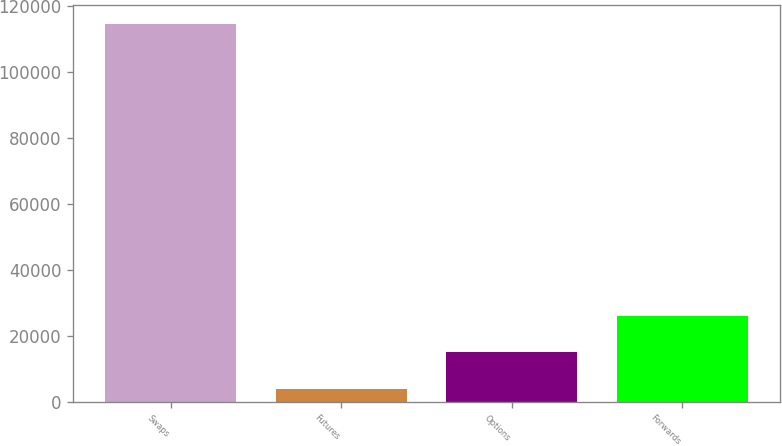Convert chart to OTSL. <chart><loc_0><loc_0><loc_500><loc_500><bar_chart><fcel>Swaps<fcel>Futures<fcel>Options<fcel>Forwards<nl><fcel>114601<fcel>3987<fcel>15048.4<fcel>26109.8<nl></chart> 